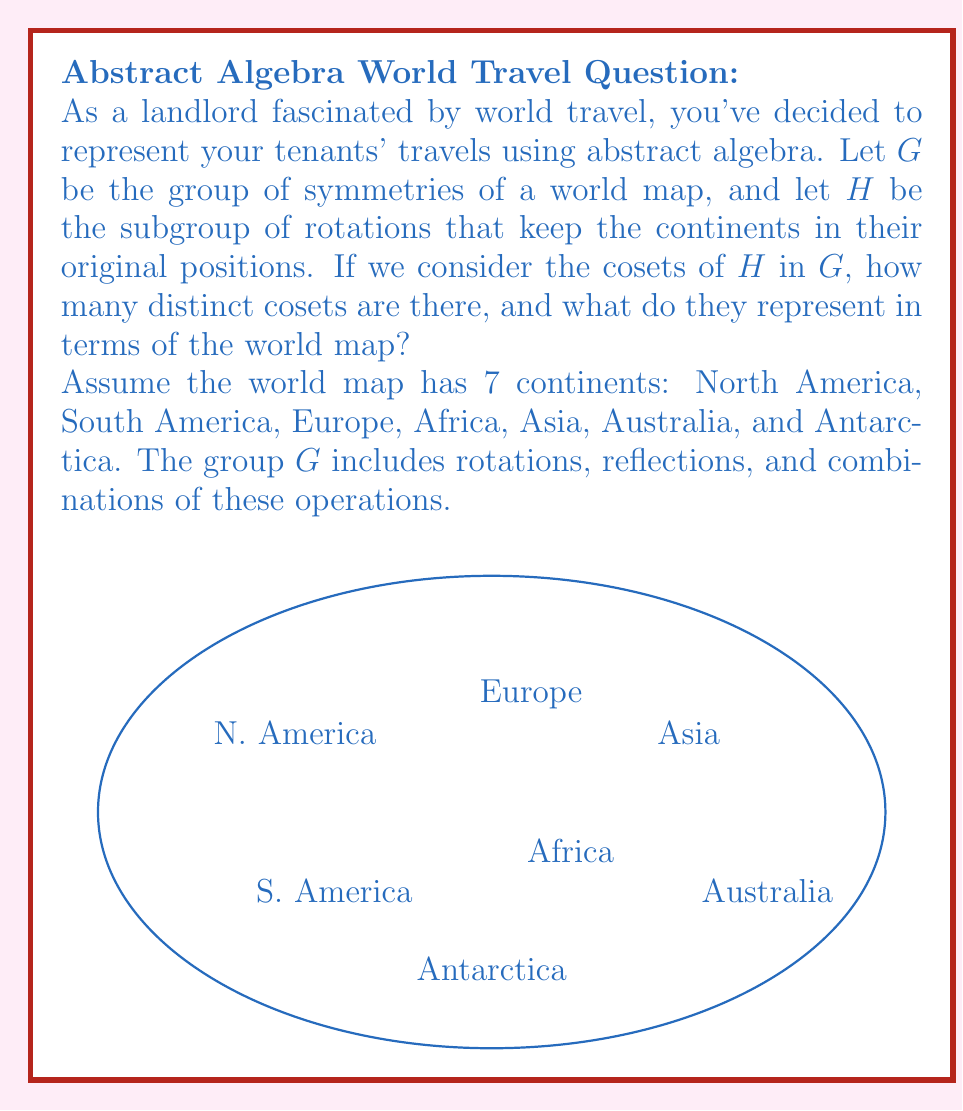Can you answer this question? Let's approach this step-by-step:

1) First, we need to understand what the group $G$ and subgroup $H$ represent:
   - $G$ is the group of all symmetries of the world map, including rotations and reflections.
   - $H$ is the subgroup of rotations that keep continents in their original positions.

2) The only rotation that keeps all continents in their original positions is the identity rotation (0°). Therefore, $H = \{e\}$, where $e$ is the identity element.

3) The number of distinct cosets of $H$ in $G$ is equal to the index of $H$ in $G$, denoted as $[G:H]$. This is also equal to the order of $G$ divided by the order of $H$:

   $$[G:H] = \frac{|G|}{|H|}$$

4) To find $|G|$, we need to count all possible symmetries:
   - There are 2 possible reflections (horizontal and vertical)
   - There are 7! = 5040 possible permutations of the 7 continents

   Therefore, $|G| = 2 \times 7! = 10080$

5) We know that $|H| = 1$ (only the identity element)

6) Now we can calculate the number of cosets:

   $$[G:H] = \frac{|G|}{|H|} = \frac{10080}{1} = 10080$$

7) Each coset represents a unique arrangement of the continents on the world map. The cosets can be thought of as:
   - $H$ itself (the identity arrangement)
   - All possible reflections and permutations of the continents

Therefore, there are 10080 distinct cosets, each representing a unique configuration of the continents on the world map.
Answer: 10080 cosets, each representing a unique arrangement of continents. 